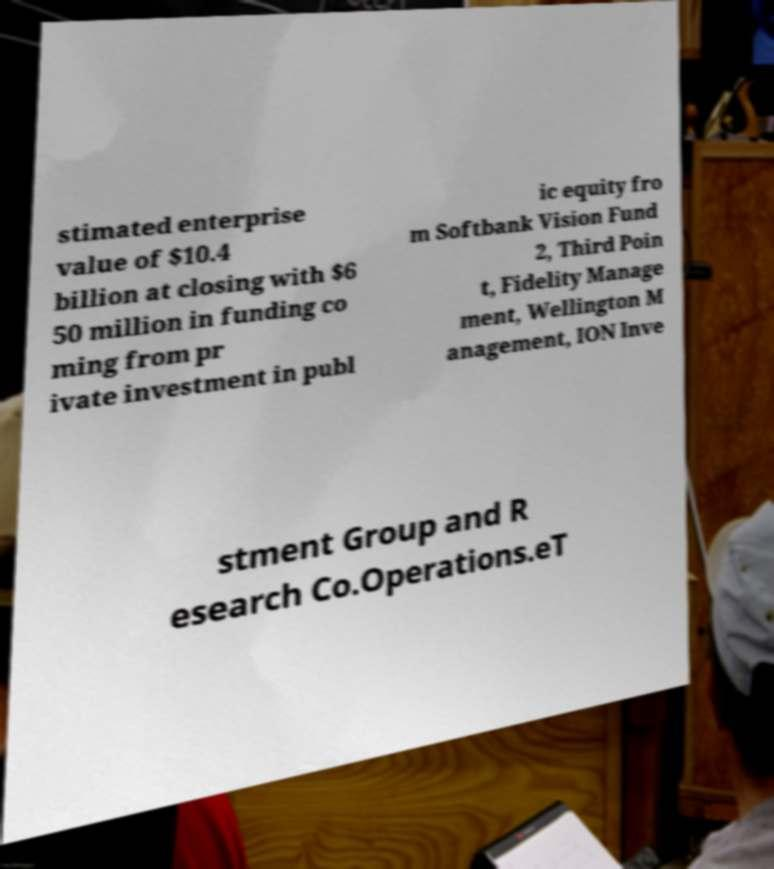For documentation purposes, I need the text within this image transcribed. Could you provide that? stimated enterprise value of $10.4 billion at closing with $6 50 million in funding co ming from pr ivate investment in publ ic equity fro m Softbank Vision Fund 2, Third Poin t, Fidelity Manage ment, Wellington M anagement, ION Inve stment Group and R esearch Co.Operations.eT 